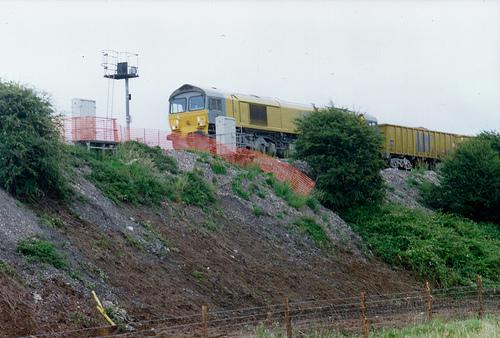Question: when was picture taken?
Choices:
A. After dark.
B. Yesterday.
C. When it was raining.
D. During daylight.
Answer with the letter. Answer: D Question: what is in front of train?
Choices:
A. A bridge.
B. A tower.
C. A car.
D. A horse.
Answer with the letter. Answer: B 